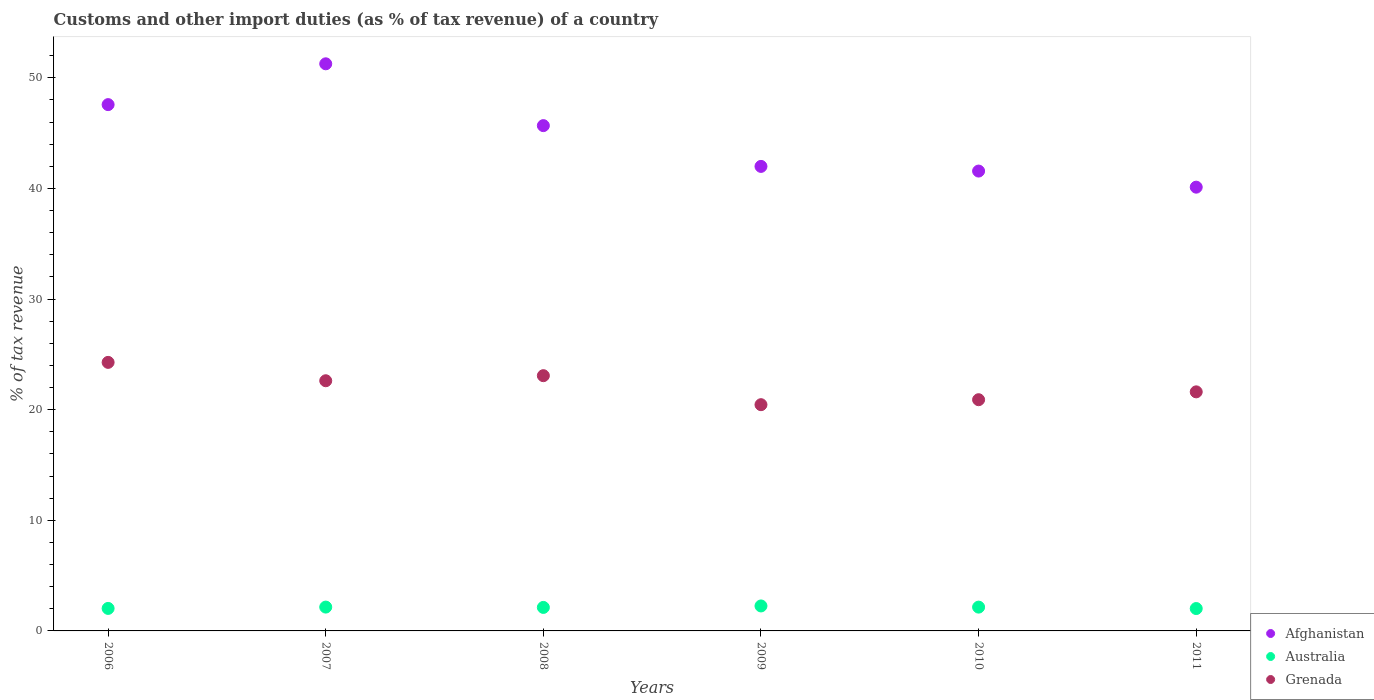How many different coloured dotlines are there?
Ensure brevity in your answer.  3. Is the number of dotlines equal to the number of legend labels?
Your answer should be very brief. Yes. What is the percentage of tax revenue from customs in Australia in 2009?
Make the answer very short. 2.26. Across all years, what is the maximum percentage of tax revenue from customs in Afghanistan?
Offer a terse response. 51.27. Across all years, what is the minimum percentage of tax revenue from customs in Afghanistan?
Give a very brief answer. 40.12. In which year was the percentage of tax revenue from customs in Afghanistan minimum?
Offer a terse response. 2011. What is the total percentage of tax revenue from customs in Grenada in the graph?
Make the answer very short. 132.94. What is the difference between the percentage of tax revenue from customs in Australia in 2010 and that in 2011?
Your answer should be very brief. 0.13. What is the difference between the percentage of tax revenue from customs in Grenada in 2007 and the percentage of tax revenue from customs in Afghanistan in 2008?
Your response must be concise. -23.06. What is the average percentage of tax revenue from customs in Afghanistan per year?
Offer a very short reply. 44.7. In the year 2006, what is the difference between the percentage of tax revenue from customs in Australia and percentage of tax revenue from customs in Grenada?
Your answer should be very brief. -22.24. What is the ratio of the percentage of tax revenue from customs in Australia in 2006 to that in 2009?
Your answer should be very brief. 0.9. What is the difference between the highest and the second highest percentage of tax revenue from customs in Australia?
Ensure brevity in your answer.  0.1. What is the difference between the highest and the lowest percentage of tax revenue from customs in Afghanistan?
Offer a very short reply. 11.15. Is it the case that in every year, the sum of the percentage of tax revenue from customs in Australia and percentage of tax revenue from customs in Grenada  is greater than the percentage of tax revenue from customs in Afghanistan?
Ensure brevity in your answer.  No. Does the percentage of tax revenue from customs in Australia monotonically increase over the years?
Keep it short and to the point. No. Is the percentage of tax revenue from customs in Grenada strictly greater than the percentage of tax revenue from customs in Afghanistan over the years?
Offer a very short reply. No. Is the percentage of tax revenue from customs in Australia strictly less than the percentage of tax revenue from customs in Afghanistan over the years?
Provide a short and direct response. Yes. How many dotlines are there?
Provide a short and direct response. 3. What is the difference between two consecutive major ticks on the Y-axis?
Ensure brevity in your answer.  10. What is the title of the graph?
Ensure brevity in your answer.  Customs and other import duties (as % of tax revenue) of a country. What is the label or title of the Y-axis?
Keep it short and to the point. % of tax revenue. What is the % of tax revenue of Afghanistan in 2006?
Give a very brief answer. 47.58. What is the % of tax revenue of Australia in 2006?
Your response must be concise. 2.03. What is the % of tax revenue of Grenada in 2006?
Provide a succinct answer. 24.28. What is the % of tax revenue in Afghanistan in 2007?
Ensure brevity in your answer.  51.27. What is the % of tax revenue of Australia in 2007?
Your answer should be very brief. 2.15. What is the % of tax revenue of Grenada in 2007?
Ensure brevity in your answer.  22.62. What is the % of tax revenue of Afghanistan in 2008?
Your response must be concise. 45.68. What is the % of tax revenue of Australia in 2008?
Offer a terse response. 2.12. What is the % of tax revenue in Grenada in 2008?
Make the answer very short. 23.08. What is the % of tax revenue in Afghanistan in 2009?
Your answer should be compact. 41.99. What is the % of tax revenue in Australia in 2009?
Your answer should be compact. 2.26. What is the % of tax revenue in Grenada in 2009?
Offer a very short reply. 20.45. What is the % of tax revenue in Afghanistan in 2010?
Give a very brief answer. 41.57. What is the % of tax revenue of Australia in 2010?
Make the answer very short. 2.15. What is the % of tax revenue of Grenada in 2010?
Provide a short and direct response. 20.9. What is the % of tax revenue of Afghanistan in 2011?
Offer a terse response. 40.12. What is the % of tax revenue of Australia in 2011?
Provide a succinct answer. 2.02. What is the % of tax revenue in Grenada in 2011?
Provide a succinct answer. 21.61. Across all years, what is the maximum % of tax revenue of Afghanistan?
Keep it short and to the point. 51.27. Across all years, what is the maximum % of tax revenue in Australia?
Give a very brief answer. 2.26. Across all years, what is the maximum % of tax revenue of Grenada?
Your response must be concise. 24.28. Across all years, what is the minimum % of tax revenue in Afghanistan?
Your answer should be compact. 40.12. Across all years, what is the minimum % of tax revenue of Australia?
Provide a succinct answer. 2.02. Across all years, what is the minimum % of tax revenue of Grenada?
Give a very brief answer. 20.45. What is the total % of tax revenue in Afghanistan in the graph?
Provide a succinct answer. 268.22. What is the total % of tax revenue of Australia in the graph?
Make the answer very short. 12.75. What is the total % of tax revenue in Grenada in the graph?
Ensure brevity in your answer.  132.94. What is the difference between the % of tax revenue in Afghanistan in 2006 and that in 2007?
Your answer should be compact. -3.69. What is the difference between the % of tax revenue in Australia in 2006 and that in 2007?
Give a very brief answer. -0.12. What is the difference between the % of tax revenue in Grenada in 2006 and that in 2007?
Provide a short and direct response. 1.66. What is the difference between the % of tax revenue of Afghanistan in 2006 and that in 2008?
Your response must be concise. 1.9. What is the difference between the % of tax revenue of Australia in 2006 and that in 2008?
Offer a very short reply. -0.09. What is the difference between the % of tax revenue in Grenada in 2006 and that in 2008?
Offer a terse response. 1.2. What is the difference between the % of tax revenue in Afghanistan in 2006 and that in 2009?
Provide a short and direct response. 5.59. What is the difference between the % of tax revenue of Australia in 2006 and that in 2009?
Provide a succinct answer. -0.22. What is the difference between the % of tax revenue of Grenada in 2006 and that in 2009?
Your answer should be very brief. 3.83. What is the difference between the % of tax revenue in Afghanistan in 2006 and that in 2010?
Make the answer very short. 6.01. What is the difference between the % of tax revenue in Australia in 2006 and that in 2010?
Offer a very short reply. -0.12. What is the difference between the % of tax revenue of Grenada in 2006 and that in 2010?
Your answer should be very brief. 3.38. What is the difference between the % of tax revenue of Afghanistan in 2006 and that in 2011?
Your answer should be very brief. 7.46. What is the difference between the % of tax revenue in Australia in 2006 and that in 2011?
Your answer should be very brief. 0.01. What is the difference between the % of tax revenue in Grenada in 2006 and that in 2011?
Offer a terse response. 2.66. What is the difference between the % of tax revenue in Afghanistan in 2007 and that in 2008?
Provide a short and direct response. 5.59. What is the difference between the % of tax revenue in Australia in 2007 and that in 2008?
Your response must be concise. 0.03. What is the difference between the % of tax revenue of Grenada in 2007 and that in 2008?
Keep it short and to the point. -0.46. What is the difference between the % of tax revenue of Afghanistan in 2007 and that in 2009?
Provide a short and direct response. 9.27. What is the difference between the % of tax revenue of Australia in 2007 and that in 2009?
Provide a succinct answer. -0.1. What is the difference between the % of tax revenue of Grenada in 2007 and that in 2009?
Give a very brief answer. 2.16. What is the difference between the % of tax revenue of Afghanistan in 2007 and that in 2010?
Offer a terse response. 9.7. What is the difference between the % of tax revenue in Australia in 2007 and that in 2010?
Give a very brief answer. 0. What is the difference between the % of tax revenue in Grenada in 2007 and that in 2010?
Offer a very short reply. 1.71. What is the difference between the % of tax revenue of Afghanistan in 2007 and that in 2011?
Your answer should be very brief. 11.15. What is the difference between the % of tax revenue in Australia in 2007 and that in 2011?
Your answer should be compact. 0.13. What is the difference between the % of tax revenue of Grenada in 2007 and that in 2011?
Give a very brief answer. 1. What is the difference between the % of tax revenue of Afghanistan in 2008 and that in 2009?
Provide a succinct answer. 3.69. What is the difference between the % of tax revenue of Australia in 2008 and that in 2009?
Your response must be concise. -0.13. What is the difference between the % of tax revenue of Grenada in 2008 and that in 2009?
Provide a succinct answer. 2.62. What is the difference between the % of tax revenue in Afghanistan in 2008 and that in 2010?
Offer a terse response. 4.11. What is the difference between the % of tax revenue in Australia in 2008 and that in 2010?
Your response must be concise. -0.03. What is the difference between the % of tax revenue of Grenada in 2008 and that in 2010?
Give a very brief answer. 2.17. What is the difference between the % of tax revenue of Afghanistan in 2008 and that in 2011?
Keep it short and to the point. 5.56. What is the difference between the % of tax revenue in Australia in 2008 and that in 2011?
Provide a succinct answer. 0.1. What is the difference between the % of tax revenue in Grenada in 2008 and that in 2011?
Provide a short and direct response. 1.46. What is the difference between the % of tax revenue of Afghanistan in 2009 and that in 2010?
Ensure brevity in your answer.  0.42. What is the difference between the % of tax revenue of Australia in 2009 and that in 2010?
Offer a very short reply. 0.11. What is the difference between the % of tax revenue in Grenada in 2009 and that in 2010?
Offer a very short reply. -0.45. What is the difference between the % of tax revenue in Afghanistan in 2009 and that in 2011?
Your response must be concise. 1.88. What is the difference between the % of tax revenue of Australia in 2009 and that in 2011?
Provide a short and direct response. 0.23. What is the difference between the % of tax revenue of Grenada in 2009 and that in 2011?
Your response must be concise. -1.16. What is the difference between the % of tax revenue in Afghanistan in 2010 and that in 2011?
Keep it short and to the point. 1.46. What is the difference between the % of tax revenue of Australia in 2010 and that in 2011?
Provide a short and direct response. 0.13. What is the difference between the % of tax revenue of Grenada in 2010 and that in 2011?
Ensure brevity in your answer.  -0.71. What is the difference between the % of tax revenue in Afghanistan in 2006 and the % of tax revenue in Australia in 2007?
Give a very brief answer. 45.43. What is the difference between the % of tax revenue in Afghanistan in 2006 and the % of tax revenue in Grenada in 2007?
Offer a very short reply. 24.96. What is the difference between the % of tax revenue of Australia in 2006 and the % of tax revenue of Grenada in 2007?
Offer a terse response. -20.58. What is the difference between the % of tax revenue in Afghanistan in 2006 and the % of tax revenue in Australia in 2008?
Offer a terse response. 45.46. What is the difference between the % of tax revenue in Afghanistan in 2006 and the % of tax revenue in Grenada in 2008?
Provide a short and direct response. 24.51. What is the difference between the % of tax revenue of Australia in 2006 and the % of tax revenue of Grenada in 2008?
Your response must be concise. -21.04. What is the difference between the % of tax revenue of Afghanistan in 2006 and the % of tax revenue of Australia in 2009?
Keep it short and to the point. 45.32. What is the difference between the % of tax revenue of Afghanistan in 2006 and the % of tax revenue of Grenada in 2009?
Provide a short and direct response. 27.13. What is the difference between the % of tax revenue of Australia in 2006 and the % of tax revenue of Grenada in 2009?
Your answer should be very brief. -18.42. What is the difference between the % of tax revenue of Afghanistan in 2006 and the % of tax revenue of Australia in 2010?
Offer a terse response. 45.43. What is the difference between the % of tax revenue of Afghanistan in 2006 and the % of tax revenue of Grenada in 2010?
Make the answer very short. 26.68. What is the difference between the % of tax revenue in Australia in 2006 and the % of tax revenue in Grenada in 2010?
Your answer should be compact. -18.87. What is the difference between the % of tax revenue of Afghanistan in 2006 and the % of tax revenue of Australia in 2011?
Your answer should be very brief. 45.56. What is the difference between the % of tax revenue of Afghanistan in 2006 and the % of tax revenue of Grenada in 2011?
Provide a short and direct response. 25.97. What is the difference between the % of tax revenue of Australia in 2006 and the % of tax revenue of Grenada in 2011?
Keep it short and to the point. -19.58. What is the difference between the % of tax revenue of Afghanistan in 2007 and the % of tax revenue of Australia in 2008?
Your response must be concise. 49.14. What is the difference between the % of tax revenue of Afghanistan in 2007 and the % of tax revenue of Grenada in 2008?
Your answer should be compact. 28.19. What is the difference between the % of tax revenue of Australia in 2007 and the % of tax revenue of Grenada in 2008?
Provide a short and direct response. -20.92. What is the difference between the % of tax revenue in Afghanistan in 2007 and the % of tax revenue in Australia in 2009?
Offer a very short reply. 49.01. What is the difference between the % of tax revenue of Afghanistan in 2007 and the % of tax revenue of Grenada in 2009?
Offer a very short reply. 30.82. What is the difference between the % of tax revenue in Australia in 2007 and the % of tax revenue in Grenada in 2009?
Your response must be concise. -18.3. What is the difference between the % of tax revenue in Afghanistan in 2007 and the % of tax revenue in Australia in 2010?
Your answer should be compact. 49.12. What is the difference between the % of tax revenue of Afghanistan in 2007 and the % of tax revenue of Grenada in 2010?
Provide a short and direct response. 30.37. What is the difference between the % of tax revenue of Australia in 2007 and the % of tax revenue of Grenada in 2010?
Your response must be concise. -18.75. What is the difference between the % of tax revenue in Afghanistan in 2007 and the % of tax revenue in Australia in 2011?
Your answer should be very brief. 49.25. What is the difference between the % of tax revenue in Afghanistan in 2007 and the % of tax revenue in Grenada in 2011?
Offer a terse response. 29.66. What is the difference between the % of tax revenue of Australia in 2007 and the % of tax revenue of Grenada in 2011?
Offer a terse response. -19.46. What is the difference between the % of tax revenue in Afghanistan in 2008 and the % of tax revenue in Australia in 2009?
Give a very brief answer. 43.42. What is the difference between the % of tax revenue in Afghanistan in 2008 and the % of tax revenue in Grenada in 2009?
Ensure brevity in your answer.  25.23. What is the difference between the % of tax revenue in Australia in 2008 and the % of tax revenue in Grenada in 2009?
Your response must be concise. -18.33. What is the difference between the % of tax revenue in Afghanistan in 2008 and the % of tax revenue in Australia in 2010?
Keep it short and to the point. 43.53. What is the difference between the % of tax revenue of Afghanistan in 2008 and the % of tax revenue of Grenada in 2010?
Keep it short and to the point. 24.78. What is the difference between the % of tax revenue in Australia in 2008 and the % of tax revenue in Grenada in 2010?
Your answer should be compact. -18.78. What is the difference between the % of tax revenue of Afghanistan in 2008 and the % of tax revenue of Australia in 2011?
Keep it short and to the point. 43.66. What is the difference between the % of tax revenue of Afghanistan in 2008 and the % of tax revenue of Grenada in 2011?
Ensure brevity in your answer.  24.07. What is the difference between the % of tax revenue in Australia in 2008 and the % of tax revenue in Grenada in 2011?
Give a very brief answer. -19.49. What is the difference between the % of tax revenue of Afghanistan in 2009 and the % of tax revenue of Australia in 2010?
Your response must be concise. 39.84. What is the difference between the % of tax revenue of Afghanistan in 2009 and the % of tax revenue of Grenada in 2010?
Your answer should be very brief. 21.09. What is the difference between the % of tax revenue in Australia in 2009 and the % of tax revenue in Grenada in 2010?
Provide a short and direct response. -18.65. What is the difference between the % of tax revenue in Afghanistan in 2009 and the % of tax revenue in Australia in 2011?
Ensure brevity in your answer.  39.97. What is the difference between the % of tax revenue in Afghanistan in 2009 and the % of tax revenue in Grenada in 2011?
Your answer should be very brief. 20.38. What is the difference between the % of tax revenue of Australia in 2009 and the % of tax revenue of Grenada in 2011?
Offer a terse response. -19.36. What is the difference between the % of tax revenue in Afghanistan in 2010 and the % of tax revenue in Australia in 2011?
Provide a succinct answer. 39.55. What is the difference between the % of tax revenue of Afghanistan in 2010 and the % of tax revenue of Grenada in 2011?
Give a very brief answer. 19.96. What is the difference between the % of tax revenue in Australia in 2010 and the % of tax revenue in Grenada in 2011?
Your answer should be compact. -19.46. What is the average % of tax revenue of Afghanistan per year?
Ensure brevity in your answer.  44.7. What is the average % of tax revenue in Australia per year?
Make the answer very short. 2.12. What is the average % of tax revenue in Grenada per year?
Your answer should be compact. 22.16. In the year 2006, what is the difference between the % of tax revenue of Afghanistan and % of tax revenue of Australia?
Offer a very short reply. 45.55. In the year 2006, what is the difference between the % of tax revenue in Afghanistan and % of tax revenue in Grenada?
Your response must be concise. 23.3. In the year 2006, what is the difference between the % of tax revenue of Australia and % of tax revenue of Grenada?
Provide a short and direct response. -22.24. In the year 2007, what is the difference between the % of tax revenue of Afghanistan and % of tax revenue of Australia?
Your response must be concise. 49.11. In the year 2007, what is the difference between the % of tax revenue in Afghanistan and % of tax revenue in Grenada?
Provide a short and direct response. 28.65. In the year 2007, what is the difference between the % of tax revenue of Australia and % of tax revenue of Grenada?
Offer a very short reply. -20.46. In the year 2008, what is the difference between the % of tax revenue of Afghanistan and % of tax revenue of Australia?
Your answer should be compact. 43.56. In the year 2008, what is the difference between the % of tax revenue in Afghanistan and % of tax revenue in Grenada?
Provide a short and direct response. 22.61. In the year 2008, what is the difference between the % of tax revenue in Australia and % of tax revenue in Grenada?
Make the answer very short. -20.95. In the year 2009, what is the difference between the % of tax revenue in Afghanistan and % of tax revenue in Australia?
Your answer should be compact. 39.74. In the year 2009, what is the difference between the % of tax revenue of Afghanistan and % of tax revenue of Grenada?
Ensure brevity in your answer.  21.54. In the year 2009, what is the difference between the % of tax revenue of Australia and % of tax revenue of Grenada?
Keep it short and to the point. -18.2. In the year 2010, what is the difference between the % of tax revenue of Afghanistan and % of tax revenue of Australia?
Ensure brevity in your answer.  39.42. In the year 2010, what is the difference between the % of tax revenue in Afghanistan and % of tax revenue in Grenada?
Keep it short and to the point. 20.67. In the year 2010, what is the difference between the % of tax revenue in Australia and % of tax revenue in Grenada?
Provide a succinct answer. -18.75. In the year 2011, what is the difference between the % of tax revenue of Afghanistan and % of tax revenue of Australia?
Provide a succinct answer. 38.09. In the year 2011, what is the difference between the % of tax revenue in Afghanistan and % of tax revenue in Grenada?
Make the answer very short. 18.5. In the year 2011, what is the difference between the % of tax revenue in Australia and % of tax revenue in Grenada?
Provide a succinct answer. -19.59. What is the ratio of the % of tax revenue in Afghanistan in 2006 to that in 2007?
Give a very brief answer. 0.93. What is the ratio of the % of tax revenue of Australia in 2006 to that in 2007?
Give a very brief answer. 0.94. What is the ratio of the % of tax revenue of Grenada in 2006 to that in 2007?
Your answer should be very brief. 1.07. What is the ratio of the % of tax revenue in Afghanistan in 2006 to that in 2008?
Your response must be concise. 1.04. What is the ratio of the % of tax revenue in Australia in 2006 to that in 2008?
Offer a very short reply. 0.96. What is the ratio of the % of tax revenue in Grenada in 2006 to that in 2008?
Your response must be concise. 1.05. What is the ratio of the % of tax revenue of Afghanistan in 2006 to that in 2009?
Provide a succinct answer. 1.13. What is the ratio of the % of tax revenue in Australia in 2006 to that in 2009?
Ensure brevity in your answer.  0.9. What is the ratio of the % of tax revenue in Grenada in 2006 to that in 2009?
Provide a succinct answer. 1.19. What is the ratio of the % of tax revenue of Afghanistan in 2006 to that in 2010?
Offer a terse response. 1.14. What is the ratio of the % of tax revenue in Australia in 2006 to that in 2010?
Your answer should be very brief. 0.95. What is the ratio of the % of tax revenue of Grenada in 2006 to that in 2010?
Ensure brevity in your answer.  1.16. What is the ratio of the % of tax revenue of Afghanistan in 2006 to that in 2011?
Ensure brevity in your answer.  1.19. What is the ratio of the % of tax revenue in Australia in 2006 to that in 2011?
Ensure brevity in your answer.  1.01. What is the ratio of the % of tax revenue in Grenada in 2006 to that in 2011?
Your answer should be compact. 1.12. What is the ratio of the % of tax revenue of Afghanistan in 2007 to that in 2008?
Offer a very short reply. 1.12. What is the ratio of the % of tax revenue in Australia in 2007 to that in 2008?
Your response must be concise. 1.01. What is the ratio of the % of tax revenue of Grenada in 2007 to that in 2008?
Ensure brevity in your answer.  0.98. What is the ratio of the % of tax revenue in Afghanistan in 2007 to that in 2009?
Keep it short and to the point. 1.22. What is the ratio of the % of tax revenue in Australia in 2007 to that in 2009?
Give a very brief answer. 0.95. What is the ratio of the % of tax revenue in Grenada in 2007 to that in 2009?
Keep it short and to the point. 1.11. What is the ratio of the % of tax revenue in Afghanistan in 2007 to that in 2010?
Keep it short and to the point. 1.23. What is the ratio of the % of tax revenue in Australia in 2007 to that in 2010?
Ensure brevity in your answer.  1. What is the ratio of the % of tax revenue in Grenada in 2007 to that in 2010?
Give a very brief answer. 1.08. What is the ratio of the % of tax revenue of Afghanistan in 2007 to that in 2011?
Ensure brevity in your answer.  1.28. What is the ratio of the % of tax revenue in Australia in 2007 to that in 2011?
Your answer should be compact. 1.06. What is the ratio of the % of tax revenue in Grenada in 2007 to that in 2011?
Offer a very short reply. 1.05. What is the ratio of the % of tax revenue in Afghanistan in 2008 to that in 2009?
Your answer should be compact. 1.09. What is the ratio of the % of tax revenue of Australia in 2008 to that in 2009?
Your answer should be compact. 0.94. What is the ratio of the % of tax revenue of Grenada in 2008 to that in 2009?
Offer a very short reply. 1.13. What is the ratio of the % of tax revenue in Afghanistan in 2008 to that in 2010?
Offer a very short reply. 1.1. What is the ratio of the % of tax revenue of Australia in 2008 to that in 2010?
Ensure brevity in your answer.  0.99. What is the ratio of the % of tax revenue in Grenada in 2008 to that in 2010?
Your response must be concise. 1.1. What is the ratio of the % of tax revenue of Afghanistan in 2008 to that in 2011?
Your response must be concise. 1.14. What is the ratio of the % of tax revenue in Australia in 2008 to that in 2011?
Your answer should be compact. 1.05. What is the ratio of the % of tax revenue in Grenada in 2008 to that in 2011?
Your response must be concise. 1.07. What is the ratio of the % of tax revenue of Afghanistan in 2009 to that in 2010?
Your answer should be very brief. 1.01. What is the ratio of the % of tax revenue in Australia in 2009 to that in 2010?
Your answer should be compact. 1.05. What is the ratio of the % of tax revenue of Grenada in 2009 to that in 2010?
Your answer should be compact. 0.98. What is the ratio of the % of tax revenue in Afghanistan in 2009 to that in 2011?
Provide a succinct answer. 1.05. What is the ratio of the % of tax revenue in Australia in 2009 to that in 2011?
Keep it short and to the point. 1.12. What is the ratio of the % of tax revenue of Grenada in 2009 to that in 2011?
Ensure brevity in your answer.  0.95. What is the ratio of the % of tax revenue in Afghanistan in 2010 to that in 2011?
Ensure brevity in your answer.  1.04. What is the ratio of the % of tax revenue in Australia in 2010 to that in 2011?
Your response must be concise. 1.06. What is the ratio of the % of tax revenue in Grenada in 2010 to that in 2011?
Keep it short and to the point. 0.97. What is the difference between the highest and the second highest % of tax revenue of Afghanistan?
Offer a terse response. 3.69. What is the difference between the highest and the second highest % of tax revenue in Australia?
Provide a short and direct response. 0.1. What is the difference between the highest and the second highest % of tax revenue in Grenada?
Provide a succinct answer. 1.2. What is the difference between the highest and the lowest % of tax revenue of Afghanistan?
Provide a short and direct response. 11.15. What is the difference between the highest and the lowest % of tax revenue in Australia?
Give a very brief answer. 0.23. What is the difference between the highest and the lowest % of tax revenue of Grenada?
Offer a terse response. 3.83. 